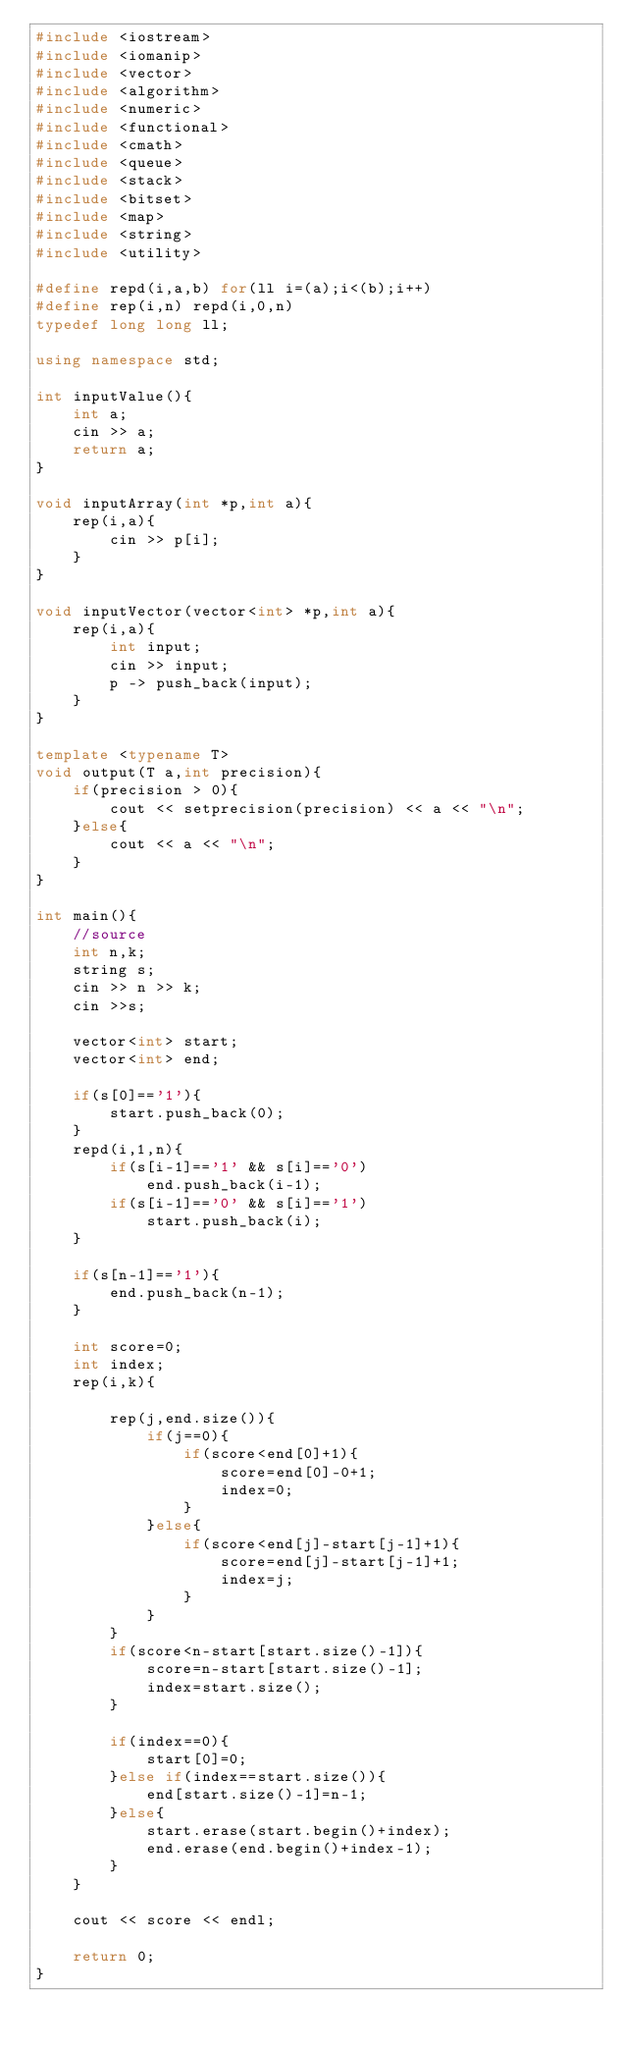Convert code to text. <code><loc_0><loc_0><loc_500><loc_500><_C++_>#include <iostream>
#include <iomanip>
#include <vector>
#include <algorithm>
#include <numeric>
#include <functional>
#include <cmath>
#include <queue>
#include <stack>
#include <bitset>
#include <map>
#include <string>
#include <utility>

#define repd(i,a,b) for(ll i=(a);i<(b);i++)
#define rep(i,n) repd(i,0,n)
typedef long long ll;

using namespace std;

int inputValue(){
	int a;
	cin >> a;
	return a;
}

void inputArray(int *p,int a){
	rep(i,a){
		cin >> p[i];
	}
}

void inputVector(vector<int> *p,int a){
	rep(i,a){
		int input;
		cin >> input;
		p -> push_back(input);
	}
}

template <typename T>
void output(T a,int precision){
	if(precision > 0){
		cout << setprecision(precision) << a << "\n";
	}else{
		cout << a << "\n";
	}
}

int main(){
	//source
	int n,k;
	string s;
	cin >> n >> k;
	cin >>s;

	vector<int> start;
	vector<int> end;

	if(s[0]=='1'){
		start.push_back(0);
	}
	repd(i,1,n){
		if(s[i-1]=='1' && s[i]=='0')
			end.push_back(i-1);
		if(s[i-1]=='0' && s[i]=='1')
			start.push_back(i);
	}

	if(s[n-1]=='1'){
		end.push_back(n-1);
	}

	int score=0;
	int index;
	rep(i,k){

		rep(j,end.size()){
			if(j==0){
				if(score<end[0]+1){
					score=end[0]-0+1;
					index=0;
				}
			}else{
				if(score<end[j]-start[j-1]+1){
					score=end[j]-start[j-1]+1;
					index=j;
				}
			}
		}
		if(score<n-start[start.size()-1]){
			score=n-start[start.size()-1];
			index=start.size();
		}

		if(index==0){
			start[0]=0;
		}else if(index==start.size()){
			end[start.size()-1]=n-1;
		}else{
			start.erase(start.begin()+index);
			end.erase(end.begin()+index-1);
		}
	}

	cout << score << endl;

	return 0;
}
</code> 